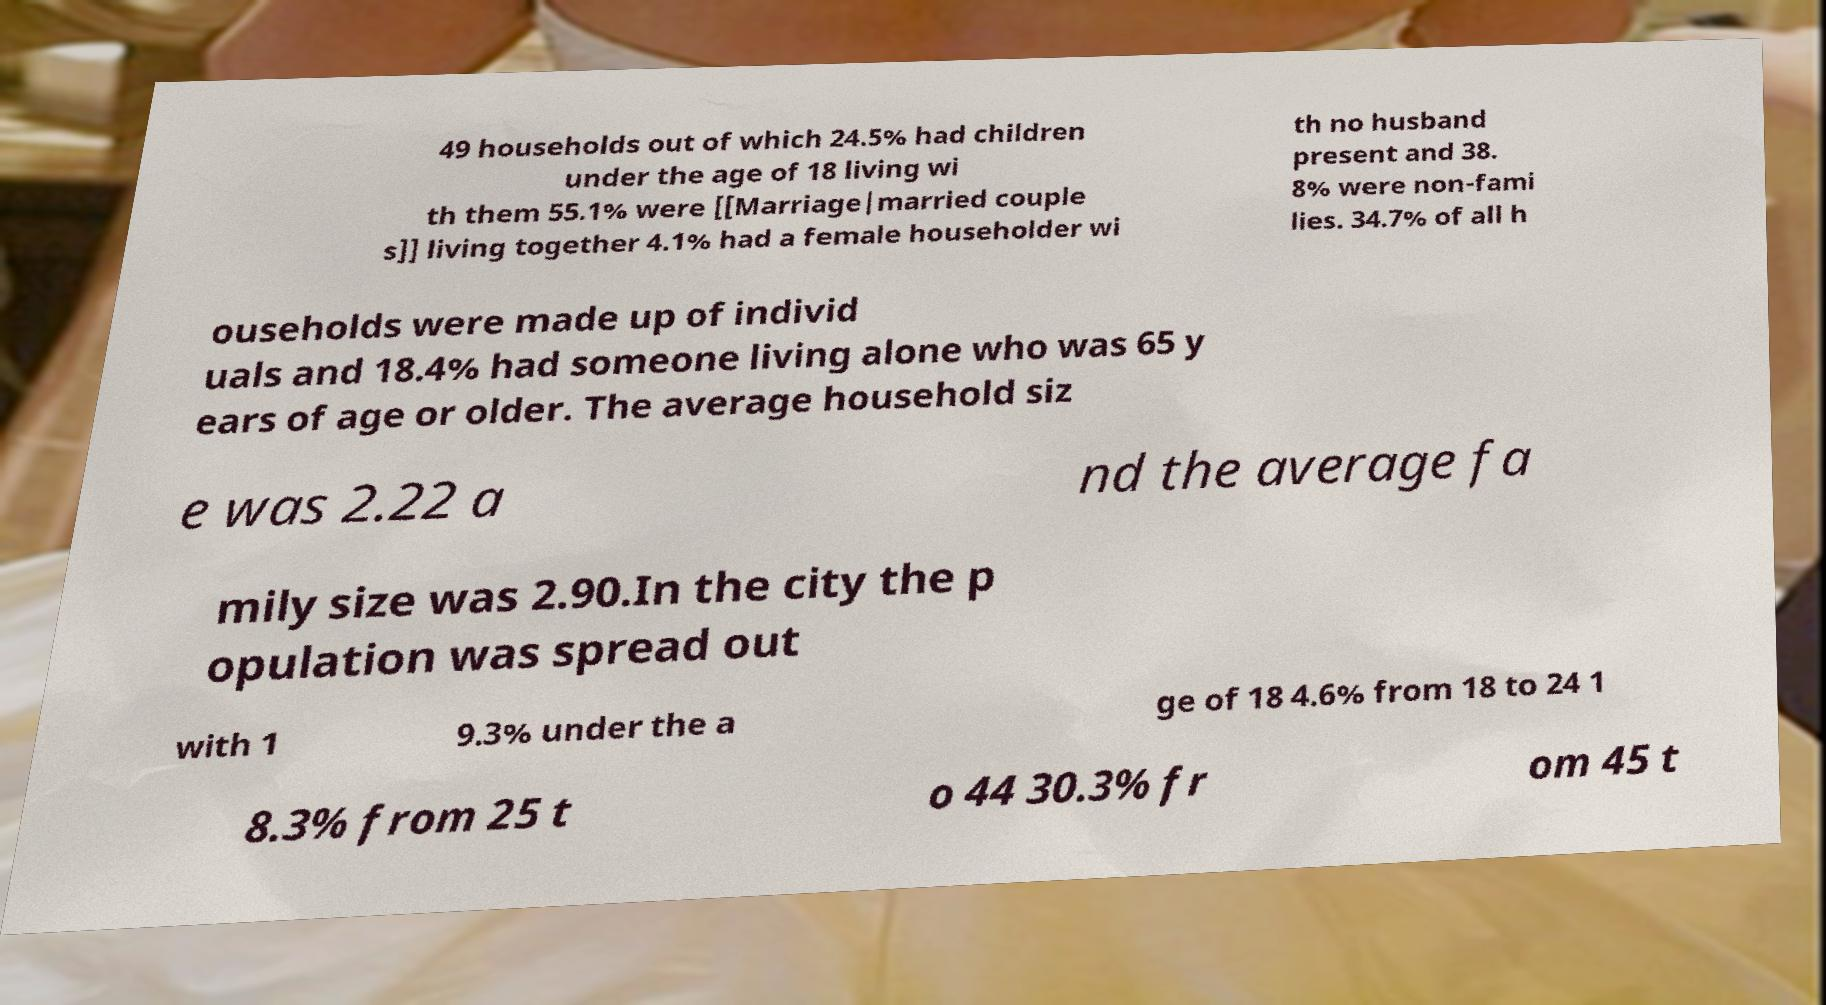Could you assist in decoding the text presented in this image and type it out clearly? 49 households out of which 24.5% had children under the age of 18 living wi th them 55.1% were [[Marriage|married couple s]] living together 4.1% had a female householder wi th no husband present and 38. 8% were non-fami lies. 34.7% of all h ouseholds were made up of individ uals and 18.4% had someone living alone who was 65 y ears of age or older. The average household siz e was 2.22 a nd the average fa mily size was 2.90.In the city the p opulation was spread out with 1 9.3% under the a ge of 18 4.6% from 18 to 24 1 8.3% from 25 t o 44 30.3% fr om 45 t 